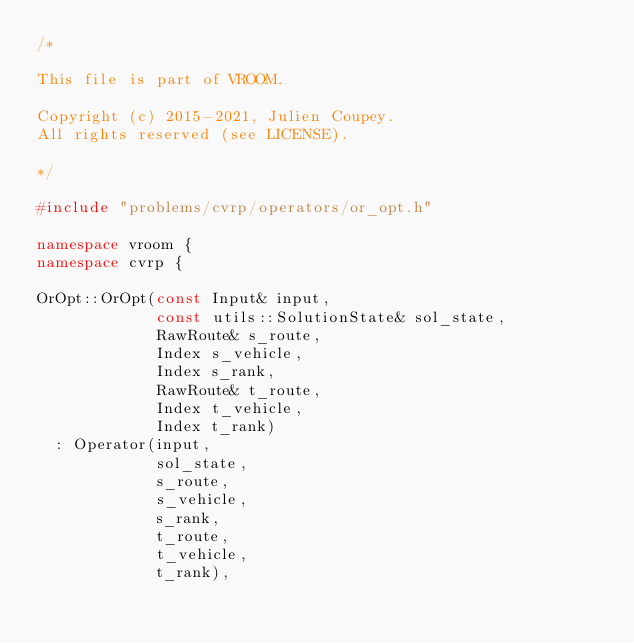Convert code to text. <code><loc_0><loc_0><loc_500><loc_500><_C++_>/*

This file is part of VROOM.

Copyright (c) 2015-2021, Julien Coupey.
All rights reserved (see LICENSE).

*/

#include "problems/cvrp/operators/or_opt.h"

namespace vroom {
namespace cvrp {

OrOpt::OrOpt(const Input& input,
             const utils::SolutionState& sol_state,
             RawRoute& s_route,
             Index s_vehicle,
             Index s_rank,
             RawRoute& t_route,
             Index t_vehicle,
             Index t_rank)
  : Operator(input,
             sol_state,
             s_route,
             s_vehicle,
             s_rank,
             t_route,
             t_vehicle,
             t_rank),</code> 